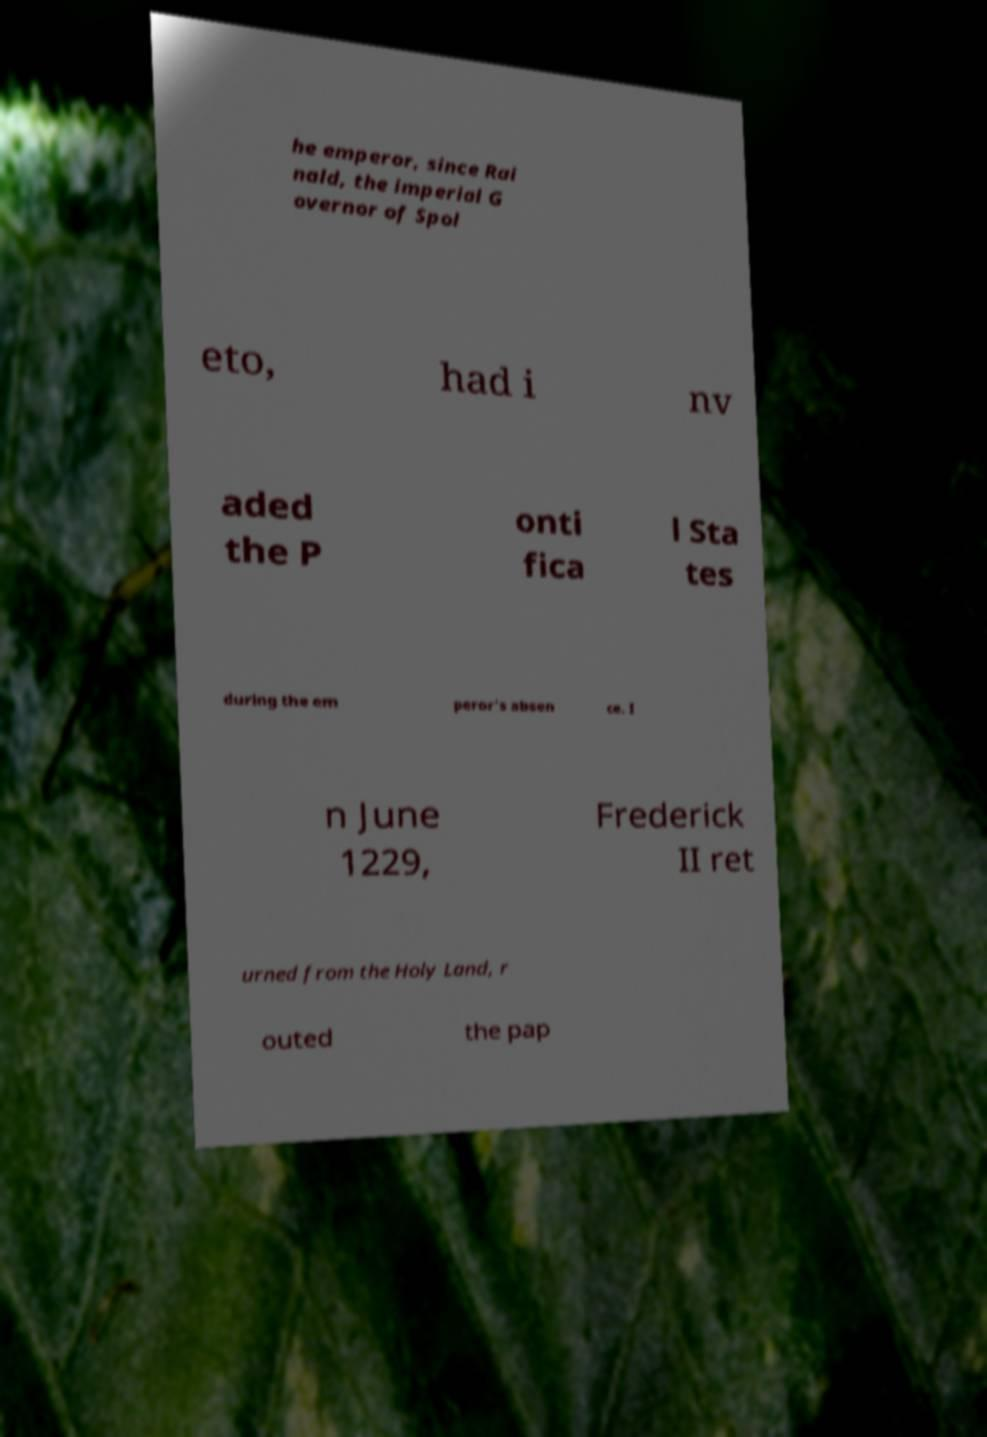Can you accurately transcribe the text from the provided image for me? he emperor, since Rai nald, the imperial G overnor of Spol eto, had i nv aded the P onti fica l Sta tes during the em peror's absen ce. I n June 1229, Frederick II ret urned from the Holy Land, r outed the pap 